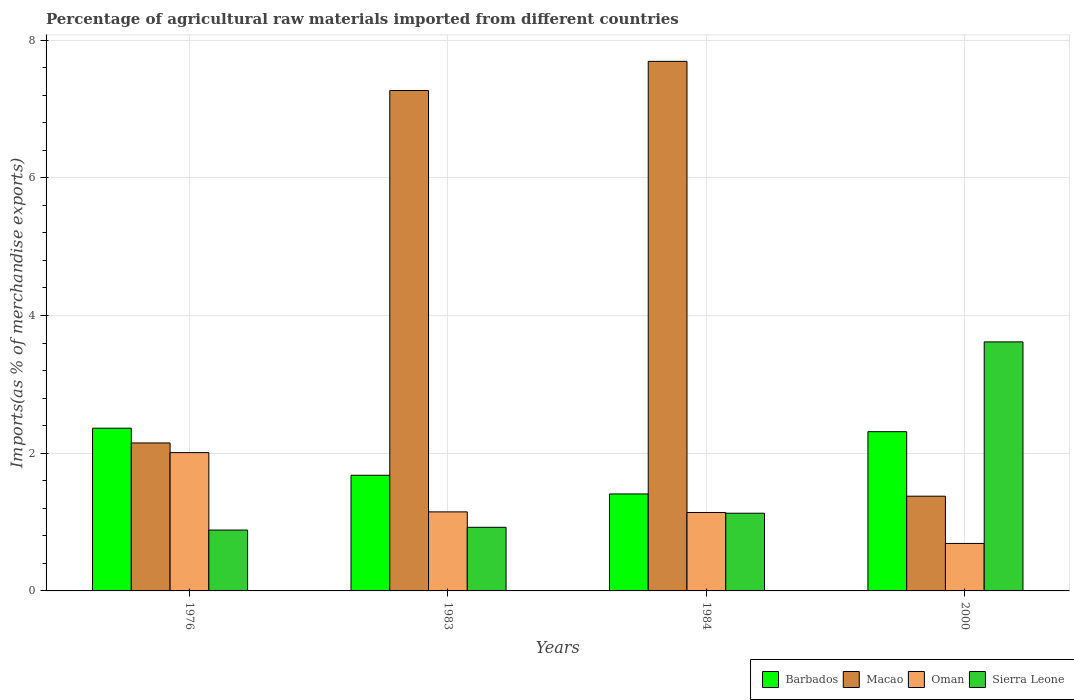Are the number of bars per tick equal to the number of legend labels?
Provide a short and direct response. Yes. What is the percentage of imports to different countries in Macao in 1983?
Offer a very short reply. 7.27. Across all years, what is the maximum percentage of imports to different countries in Oman?
Make the answer very short. 2.01. Across all years, what is the minimum percentage of imports to different countries in Sierra Leone?
Your answer should be compact. 0.88. In which year was the percentage of imports to different countries in Oman maximum?
Provide a succinct answer. 1976. In which year was the percentage of imports to different countries in Oman minimum?
Keep it short and to the point. 2000. What is the total percentage of imports to different countries in Oman in the graph?
Make the answer very short. 4.99. What is the difference between the percentage of imports to different countries in Sierra Leone in 1983 and that in 1984?
Offer a very short reply. -0.2. What is the difference between the percentage of imports to different countries in Macao in 1976 and the percentage of imports to different countries in Barbados in 1983?
Offer a terse response. 0.47. What is the average percentage of imports to different countries in Macao per year?
Ensure brevity in your answer.  4.62. In the year 1976, what is the difference between the percentage of imports to different countries in Barbados and percentage of imports to different countries in Sierra Leone?
Your answer should be compact. 1.48. In how many years, is the percentage of imports to different countries in Barbados greater than 4 %?
Provide a short and direct response. 0. What is the ratio of the percentage of imports to different countries in Oman in 1983 to that in 1984?
Keep it short and to the point. 1.01. Is the percentage of imports to different countries in Macao in 1976 less than that in 2000?
Offer a very short reply. No. Is the difference between the percentage of imports to different countries in Barbados in 1976 and 1984 greater than the difference between the percentage of imports to different countries in Sierra Leone in 1976 and 1984?
Provide a succinct answer. Yes. What is the difference between the highest and the second highest percentage of imports to different countries in Macao?
Give a very brief answer. 0.42. What is the difference between the highest and the lowest percentage of imports to different countries in Oman?
Your answer should be very brief. 1.32. Is it the case that in every year, the sum of the percentage of imports to different countries in Macao and percentage of imports to different countries in Oman is greater than the sum of percentage of imports to different countries in Barbados and percentage of imports to different countries in Sierra Leone?
Offer a very short reply. Yes. What does the 2nd bar from the left in 2000 represents?
Ensure brevity in your answer.  Macao. What does the 3rd bar from the right in 1976 represents?
Provide a succinct answer. Macao. Is it the case that in every year, the sum of the percentage of imports to different countries in Oman and percentage of imports to different countries in Macao is greater than the percentage of imports to different countries in Barbados?
Your response must be concise. No. How many bars are there?
Ensure brevity in your answer.  16. Are all the bars in the graph horizontal?
Provide a succinct answer. No. What is the difference between two consecutive major ticks on the Y-axis?
Offer a terse response. 2. Are the values on the major ticks of Y-axis written in scientific E-notation?
Your answer should be compact. No. Does the graph contain any zero values?
Ensure brevity in your answer.  No. How many legend labels are there?
Make the answer very short. 4. What is the title of the graph?
Your response must be concise. Percentage of agricultural raw materials imported from different countries. What is the label or title of the Y-axis?
Ensure brevity in your answer.  Imports(as % of merchandise exports). What is the Imports(as % of merchandise exports) in Barbados in 1976?
Your answer should be very brief. 2.36. What is the Imports(as % of merchandise exports) in Macao in 1976?
Keep it short and to the point. 2.15. What is the Imports(as % of merchandise exports) of Oman in 1976?
Make the answer very short. 2.01. What is the Imports(as % of merchandise exports) in Sierra Leone in 1976?
Your answer should be very brief. 0.88. What is the Imports(as % of merchandise exports) of Barbados in 1983?
Your answer should be compact. 1.68. What is the Imports(as % of merchandise exports) in Macao in 1983?
Provide a short and direct response. 7.27. What is the Imports(as % of merchandise exports) in Oman in 1983?
Offer a terse response. 1.15. What is the Imports(as % of merchandise exports) in Sierra Leone in 1983?
Give a very brief answer. 0.92. What is the Imports(as % of merchandise exports) of Barbados in 1984?
Keep it short and to the point. 1.41. What is the Imports(as % of merchandise exports) in Macao in 1984?
Offer a very short reply. 7.69. What is the Imports(as % of merchandise exports) in Oman in 1984?
Offer a terse response. 1.14. What is the Imports(as % of merchandise exports) of Sierra Leone in 1984?
Your answer should be very brief. 1.13. What is the Imports(as % of merchandise exports) of Barbados in 2000?
Ensure brevity in your answer.  2.31. What is the Imports(as % of merchandise exports) of Macao in 2000?
Make the answer very short. 1.38. What is the Imports(as % of merchandise exports) of Oman in 2000?
Keep it short and to the point. 0.69. What is the Imports(as % of merchandise exports) in Sierra Leone in 2000?
Give a very brief answer. 3.62. Across all years, what is the maximum Imports(as % of merchandise exports) of Barbados?
Give a very brief answer. 2.36. Across all years, what is the maximum Imports(as % of merchandise exports) in Macao?
Keep it short and to the point. 7.69. Across all years, what is the maximum Imports(as % of merchandise exports) in Oman?
Keep it short and to the point. 2.01. Across all years, what is the maximum Imports(as % of merchandise exports) in Sierra Leone?
Your answer should be compact. 3.62. Across all years, what is the minimum Imports(as % of merchandise exports) of Barbados?
Keep it short and to the point. 1.41. Across all years, what is the minimum Imports(as % of merchandise exports) in Macao?
Keep it short and to the point. 1.38. Across all years, what is the minimum Imports(as % of merchandise exports) in Oman?
Provide a short and direct response. 0.69. Across all years, what is the minimum Imports(as % of merchandise exports) of Sierra Leone?
Provide a succinct answer. 0.88. What is the total Imports(as % of merchandise exports) in Barbados in the graph?
Make the answer very short. 7.76. What is the total Imports(as % of merchandise exports) of Macao in the graph?
Your answer should be very brief. 18.48. What is the total Imports(as % of merchandise exports) of Oman in the graph?
Ensure brevity in your answer.  4.99. What is the total Imports(as % of merchandise exports) in Sierra Leone in the graph?
Your answer should be very brief. 6.55. What is the difference between the Imports(as % of merchandise exports) of Barbados in 1976 and that in 1983?
Your response must be concise. 0.68. What is the difference between the Imports(as % of merchandise exports) of Macao in 1976 and that in 1983?
Your answer should be very brief. -5.12. What is the difference between the Imports(as % of merchandise exports) of Oman in 1976 and that in 1983?
Your answer should be compact. 0.86. What is the difference between the Imports(as % of merchandise exports) in Sierra Leone in 1976 and that in 1983?
Offer a very short reply. -0.04. What is the difference between the Imports(as % of merchandise exports) of Barbados in 1976 and that in 1984?
Provide a succinct answer. 0.95. What is the difference between the Imports(as % of merchandise exports) of Macao in 1976 and that in 1984?
Offer a terse response. -5.54. What is the difference between the Imports(as % of merchandise exports) in Oman in 1976 and that in 1984?
Give a very brief answer. 0.87. What is the difference between the Imports(as % of merchandise exports) of Sierra Leone in 1976 and that in 1984?
Keep it short and to the point. -0.24. What is the difference between the Imports(as % of merchandise exports) of Barbados in 1976 and that in 2000?
Your response must be concise. 0.05. What is the difference between the Imports(as % of merchandise exports) of Macao in 1976 and that in 2000?
Make the answer very short. 0.77. What is the difference between the Imports(as % of merchandise exports) in Oman in 1976 and that in 2000?
Provide a succinct answer. 1.32. What is the difference between the Imports(as % of merchandise exports) in Sierra Leone in 1976 and that in 2000?
Give a very brief answer. -2.73. What is the difference between the Imports(as % of merchandise exports) of Barbados in 1983 and that in 1984?
Offer a very short reply. 0.27. What is the difference between the Imports(as % of merchandise exports) in Macao in 1983 and that in 1984?
Provide a succinct answer. -0.42. What is the difference between the Imports(as % of merchandise exports) of Oman in 1983 and that in 1984?
Provide a succinct answer. 0.01. What is the difference between the Imports(as % of merchandise exports) in Sierra Leone in 1983 and that in 1984?
Offer a very short reply. -0.2. What is the difference between the Imports(as % of merchandise exports) in Barbados in 1983 and that in 2000?
Your answer should be compact. -0.63. What is the difference between the Imports(as % of merchandise exports) in Macao in 1983 and that in 2000?
Offer a terse response. 5.89. What is the difference between the Imports(as % of merchandise exports) of Oman in 1983 and that in 2000?
Provide a succinct answer. 0.46. What is the difference between the Imports(as % of merchandise exports) in Sierra Leone in 1983 and that in 2000?
Your answer should be compact. -2.69. What is the difference between the Imports(as % of merchandise exports) of Barbados in 1984 and that in 2000?
Your answer should be very brief. -0.9. What is the difference between the Imports(as % of merchandise exports) in Macao in 1984 and that in 2000?
Provide a succinct answer. 6.32. What is the difference between the Imports(as % of merchandise exports) of Oman in 1984 and that in 2000?
Provide a succinct answer. 0.45. What is the difference between the Imports(as % of merchandise exports) in Sierra Leone in 1984 and that in 2000?
Provide a succinct answer. -2.49. What is the difference between the Imports(as % of merchandise exports) in Barbados in 1976 and the Imports(as % of merchandise exports) in Macao in 1983?
Give a very brief answer. -4.9. What is the difference between the Imports(as % of merchandise exports) in Barbados in 1976 and the Imports(as % of merchandise exports) in Oman in 1983?
Provide a succinct answer. 1.22. What is the difference between the Imports(as % of merchandise exports) of Barbados in 1976 and the Imports(as % of merchandise exports) of Sierra Leone in 1983?
Provide a succinct answer. 1.44. What is the difference between the Imports(as % of merchandise exports) of Macao in 1976 and the Imports(as % of merchandise exports) of Oman in 1983?
Offer a very short reply. 1. What is the difference between the Imports(as % of merchandise exports) in Macao in 1976 and the Imports(as % of merchandise exports) in Sierra Leone in 1983?
Keep it short and to the point. 1.23. What is the difference between the Imports(as % of merchandise exports) of Oman in 1976 and the Imports(as % of merchandise exports) of Sierra Leone in 1983?
Provide a succinct answer. 1.09. What is the difference between the Imports(as % of merchandise exports) in Barbados in 1976 and the Imports(as % of merchandise exports) in Macao in 1984?
Ensure brevity in your answer.  -5.33. What is the difference between the Imports(as % of merchandise exports) in Barbados in 1976 and the Imports(as % of merchandise exports) in Oman in 1984?
Give a very brief answer. 1.22. What is the difference between the Imports(as % of merchandise exports) in Barbados in 1976 and the Imports(as % of merchandise exports) in Sierra Leone in 1984?
Ensure brevity in your answer.  1.24. What is the difference between the Imports(as % of merchandise exports) in Macao in 1976 and the Imports(as % of merchandise exports) in Oman in 1984?
Provide a short and direct response. 1.01. What is the difference between the Imports(as % of merchandise exports) of Oman in 1976 and the Imports(as % of merchandise exports) of Sierra Leone in 1984?
Your response must be concise. 0.88. What is the difference between the Imports(as % of merchandise exports) in Barbados in 1976 and the Imports(as % of merchandise exports) in Macao in 2000?
Your answer should be compact. 0.99. What is the difference between the Imports(as % of merchandise exports) of Barbados in 1976 and the Imports(as % of merchandise exports) of Oman in 2000?
Make the answer very short. 1.67. What is the difference between the Imports(as % of merchandise exports) in Barbados in 1976 and the Imports(as % of merchandise exports) in Sierra Leone in 2000?
Provide a short and direct response. -1.25. What is the difference between the Imports(as % of merchandise exports) in Macao in 1976 and the Imports(as % of merchandise exports) in Oman in 2000?
Your answer should be very brief. 1.46. What is the difference between the Imports(as % of merchandise exports) in Macao in 1976 and the Imports(as % of merchandise exports) in Sierra Leone in 2000?
Your response must be concise. -1.47. What is the difference between the Imports(as % of merchandise exports) of Oman in 1976 and the Imports(as % of merchandise exports) of Sierra Leone in 2000?
Provide a short and direct response. -1.61. What is the difference between the Imports(as % of merchandise exports) of Barbados in 1983 and the Imports(as % of merchandise exports) of Macao in 1984?
Your answer should be compact. -6.01. What is the difference between the Imports(as % of merchandise exports) of Barbados in 1983 and the Imports(as % of merchandise exports) of Oman in 1984?
Ensure brevity in your answer.  0.54. What is the difference between the Imports(as % of merchandise exports) in Barbados in 1983 and the Imports(as % of merchandise exports) in Sierra Leone in 1984?
Your answer should be very brief. 0.55. What is the difference between the Imports(as % of merchandise exports) of Macao in 1983 and the Imports(as % of merchandise exports) of Oman in 1984?
Offer a terse response. 6.13. What is the difference between the Imports(as % of merchandise exports) of Macao in 1983 and the Imports(as % of merchandise exports) of Sierra Leone in 1984?
Provide a short and direct response. 6.14. What is the difference between the Imports(as % of merchandise exports) of Oman in 1983 and the Imports(as % of merchandise exports) of Sierra Leone in 1984?
Your response must be concise. 0.02. What is the difference between the Imports(as % of merchandise exports) of Barbados in 1983 and the Imports(as % of merchandise exports) of Macao in 2000?
Ensure brevity in your answer.  0.3. What is the difference between the Imports(as % of merchandise exports) in Barbados in 1983 and the Imports(as % of merchandise exports) in Oman in 2000?
Provide a succinct answer. 0.99. What is the difference between the Imports(as % of merchandise exports) in Barbados in 1983 and the Imports(as % of merchandise exports) in Sierra Leone in 2000?
Your answer should be compact. -1.94. What is the difference between the Imports(as % of merchandise exports) in Macao in 1983 and the Imports(as % of merchandise exports) in Oman in 2000?
Give a very brief answer. 6.58. What is the difference between the Imports(as % of merchandise exports) in Macao in 1983 and the Imports(as % of merchandise exports) in Sierra Leone in 2000?
Give a very brief answer. 3.65. What is the difference between the Imports(as % of merchandise exports) of Oman in 1983 and the Imports(as % of merchandise exports) of Sierra Leone in 2000?
Give a very brief answer. -2.47. What is the difference between the Imports(as % of merchandise exports) of Barbados in 1984 and the Imports(as % of merchandise exports) of Macao in 2000?
Provide a succinct answer. 0.03. What is the difference between the Imports(as % of merchandise exports) in Barbados in 1984 and the Imports(as % of merchandise exports) in Oman in 2000?
Keep it short and to the point. 0.72. What is the difference between the Imports(as % of merchandise exports) in Barbados in 1984 and the Imports(as % of merchandise exports) in Sierra Leone in 2000?
Provide a short and direct response. -2.21. What is the difference between the Imports(as % of merchandise exports) in Macao in 1984 and the Imports(as % of merchandise exports) in Oman in 2000?
Ensure brevity in your answer.  7. What is the difference between the Imports(as % of merchandise exports) of Macao in 1984 and the Imports(as % of merchandise exports) of Sierra Leone in 2000?
Your answer should be very brief. 4.07. What is the difference between the Imports(as % of merchandise exports) in Oman in 1984 and the Imports(as % of merchandise exports) in Sierra Leone in 2000?
Your response must be concise. -2.48. What is the average Imports(as % of merchandise exports) in Barbados per year?
Give a very brief answer. 1.94. What is the average Imports(as % of merchandise exports) of Macao per year?
Offer a very short reply. 4.62. What is the average Imports(as % of merchandise exports) of Oman per year?
Make the answer very short. 1.25. What is the average Imports(as % of merchandise exports) in Sierra Leone per year?
Your response must be concise. 1.64. In the year 1976, what is the difference between the Imports(as % of merchandise exports) in Barbados and Imports(as % of merchandise exports) in Macao?
Your response must be concise. 0.21. In the year 1976, what is the difference between the Imports(as % of merchandise exports) in Barbados and Imports(as % of merchandise exports) in Oman?
Ensure brevity in your answer.  0.35. In the year 1976, what is the difference between the Imports(as % of merchandise exports) in Barbados and Imports(as % of merchandise exports) in Sierra Leone?
Provide a short and direct response. 1.48. In the year 1976, what is the difference between the Imports(as % of merchandise exports) in Macao and Imports(as % of merchandise exports) in Oman?
Give a very brief answer. 0.14. In the year 1976, what is the difference between the Imports(as % of merchandise exports) of Macao and Imports(as % of merchandise exports) of Sierra Leone?
Provide a succinct answer. 1.27. In the year 1976, what is the difference between the Imports(as % of merchandise exports) in Oman and Imports(as % of merchandise exports) in Sierra Leone?
Ensure brevity in your answer.  1.13. In the year 1983, what is the difference between the Imports(as % of merchandise exports) of Barbados and Imports(as % of merchandise exports) of Macao?
Keep it short and to the point. -5.59. In the year 1983, what is the difference between the Imports(as % of merchandise exports) of Barbados and Imports(as % of merchandise exports) of Oman?
Provide a succinct answer. 0.53. In the year 1983, what is the difference between the Imports(as % of merchandise exports) of Barbados and Imports(as % of merchandise exports) of Sierra Leone?
Your answer should be very brief. 0.76. In the year 1983, what is the difference between the Imports(as % of merchandise exports) of Macao and Imports(as % of merchandise exports) of Oman?
Make the answer very short. 6.12. In the year 1983, what is the difference between the Imports(as % of merchandise exports) in Macao and Imports(as % of merchandise exports) in Sierra Leone?
Provide a short and direct response. 6.34. In the year 1983, what is the difference between the Imports(as % of merchandise exports) in Oman and Imports(as % of merchandise exports) in Sierra Leone?
Provide a succinct answer. 0.22. In the year 1984, what is the difference between the Imports(as % of merchandise exports) of Barbados and Imports(as % of merchandise exports) of Macao?
Your answer should be compact. -6.28. In the year 1984, what is the difference between the Imports(as % of merchandise exports) of Barbados and Imports(as % of merchandise exports) of Oman?
Ensure brevity in your answer.  0.27. In the year 1984, what is the difference between the Imports(as % of merchandise exports) in Barbados and Imports(as % of merchandise exports) in Sierra Leone?
Your response must be concise. 0.28. In the year 1984, what is the difference between the Imports(as % of merchandise exports) in Macao and Imports(as % of merchandise exports) in Oman?
Provide a succinct answer. 6.55. In the year 1984, what is the difference between the Imports(as % of merchandise exports) in Macao and Imports(as % of merchandise exports) in Sierra Leone?
Offer a very short reply. 6.56. In the year 1984, what is the difference between the Imports(as % of merchandise exports) in Oman and Imports(as % of merchandise exports) in Sierra Leone?
Ensure brevity in your answer.  0.01. In the year 2000, what is the difference between the Imports(as % of merchandise exports) in Barbados and Imports(as % of merchandise exports) in Macao?
Your answer should be very brief. 0.94. In the year 2000, what is the difference between the Imports(as % of merchandise exports) of Barbados and Imports(as % of merchandise exports) of Oman?
Your answer should be compact. 1.62. In the year 2000, what is the difference between the Imports(as % of merchandise exports) of Barbados and Imports(as % of merchandise exports) of Sierra Leone?
Make the answer very short. -1.3. In the year 2000, what is the difference between the Imports(as % of merchandise exports) in Macao and Imports(as % of merchandise exports) in Oman?
Your response must be concise. 0.69. In the year 2000, what is the difference between the Imports(as % of merchandise exports) of Macao and Imports(as % of merchandise exports) of Sierra Leone?
Your response must be concise. -2.24. In the year 2000, what is the difference between the Imports(as % of merchandise exports) of Oman and Imports(as % of merchandise exports) of Sierra Leone?
Offer a very short reply. -2.93. What is the ratio of the Imports(as % of merchandise exports) in Barbados in 1976 to that in 1983?
Make the answer very short. 1.41. What is the ratio of the Imports(as % of merchandise exports) in Macao in 1976 to that in 1983?
Give a very brief answer. 0.3. What is the ratio of the Imports(as % of merchandise exports) in Oman in 1976 to that in 1983?
Provide a succinct answer. 1.75. What is the ratio of the Imports(as % of merchandise exports) of Sierra Leone in 1976 to that in 1983?
Offer a terse response. 0.96. What is the ratio of the Imports(as % of merchandise exports) in Barbados in 1976 to that in 1984?
Make the answer very short. 1.68. What is the ratio of the Imports(as % of merchandise exports) of Macao in 1976 to that in 1984?
Provide a short and direct response. 0.28. What is the ratio of the Imports(as % of merchandise exports) of Oman in 1976 to that in 1984?
Offer a terse response. 1.76. What is the ratio of the Imports(as % of merchandise exports) of Sierra Leone in 1976 to that in 1984?
Offer a terse response. 0.78. What is the ratio of the Imports(as % of merchandise exports) of Barbados in 1976 to that in 2000?
Make the answer very short. 1.02. What is the ratio of the Imports(as % of merchandise exports) of Macao in 1976 to that in 2000?
Provide a short and direct response. 1.56. What is the ratio of the Imports(as % of merchandise exports) in Oman in 1976 to that in 2000?
Your response must be concise. 2.91. What is the ratio of the Imports(as % of merchandise exports) in Sierra Leone in 1976 to that in 2000?
Make the answer very short. 0.24. What is the ratio of the Imports(as % of merchandise exports) in Barbados in 1983 to that in 1984?
Provide a short and direct response. 1.19. What is the ratio of the Imports(as % of merchandise exports) in Macao in 1983 to that in 1984?
Provide a succinct answer. 0.94. What is the ratio of the Imports(as % of merchandise exports) in Sierra Leone in 1983 to that in 1984?
Your response must be concise. 0.82. What is the ratio of the Imports(as % of merchandise exports) of Barbados in 1983 to that in 2000?
Offer a terse response. 0.73. What is the ratio of the Imports(as % of merchandise exports) in Macao in 1983 to that in 2000?
Ensure brevity in your answer.  5.28. What is the ratio of the Imports(as % of merchandise exports) in Oman in 1983 to that in 2000?
Keep it short and to the point. 1.66. What is the ratio of the Imports(as % of merchandise exports) of Sierra Leone in 1983 to that in 2000?
Make the answer very short. 0.26. What is the ratio of the Imports(as % of merchandise exports) in Barbados in 1984 to that in 2000?
Make the answer very short. 0.61. What is the ratio of the Imports(as % of merchandise exports) in Macao in 1984 to that in 2000?
Make the answer very short. 5.59. What is the ratio of the Imports(as % of merchandise exports) of Oman in 1984 to that in 2000?
Keep it short and to the point. 1.65. What is the ratio of the Imports(as % of merchandise exports) of Sierra Leone in 1984 to that in 2000?
Your response must be concise. 0.31. What is the difference between the highest and the second highest Imports(as % of merchandise exports) in Barbados?
Ensure brevity in your answer.  0.05. What is the difference between the highest and the second highest Imports(as % of merchandise exports) of Macao?
Keep it short and to the point. 0.42. What is the difference between the highest and the second highest Imports(as % of merchandise exports) in Oman?
Offer a very short reply. 0.86. What is the difference between the highest and the second highest Imports(as % of merchandise exports) in Sierra Leone?
Your answer should be very brief. 2.49. What is the difference between the highest and the lowest Imports(as % of merchandise exports) of Barbados?
Give a very brief answer. 0.95. What is the difference between the highest and the lowest Imports(as % of merchandise exports) of Macao?
Give a very brief answer. 6.32. What is the difference between the highest and the lowest Imports(as % of merchandise exports) in Oman?
Provide a succinct answer. 1.32. What is the difference between the highest and the lowest Imports(as % of merchandise exports) in Sierra Leone?
Your response must be concise. 2.73. 